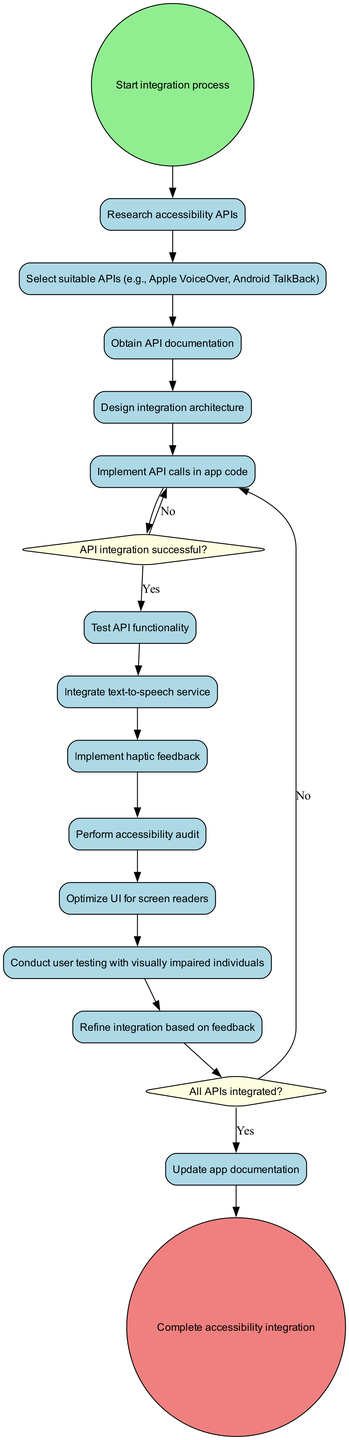What is the initial node of the diagram? The initial node of the diagram is "Start integration process." It is specified in the data provided under "initialNode."
Answer: Start integration process How many activities are present in the diagram? There are a total of 13 activities listed in the "activities" section of the data.
Answer: 13 What is the action taken after "Implement API calls in app code"? After "Implement API calls in app code," the diagram proceeds to a decision node labeled "API integration successful?" This connection indicates what happens next based on the success of the API integration.
Answer: API integration successful? How many decision nodes are there? The diagram has 2 decision nodes specified in the "decisionNodes" section of the data.
Answer: 2 What is the final node of the diagram? The final node of the diagram is "Complete accessibility integration." It is found as the last node in the diagram, indicating the end of the process.
Answer: Complete accessibility integration What happens if the API integration is not successful? If the API integration is not successful, the flow returns to the same activity "Implement API calls in app code," as indicated by the edge labeled "No" from the decision node. This signifies that debugging and retrying is required.
Answer: Debug and retry Which activities follow the decision "All APIs integrated?"? After the decision "All APIs integrated?", if the answer is "Yes," the process moves to the testing phase. If "No," it continues API integration, indicated by the edges connecting from this decision node.
Answer: Move to testing phase or Continue API integration What activity directly precedes "Conduct user testing with visually impaired individuals"? The activity directly preceding "Conduct user testing with visually impaired individuals" is "Refine integration based on feedback." This is determined by following the linear flow of activities in the diagram.
Answer: Refine integration based on feedback What decision must be made after "Test API functionality"? After "Test API functionality," the decision made is, "API integration successful?" This determines whether to proceed or debug and retry.
Answer: API integration successful? 